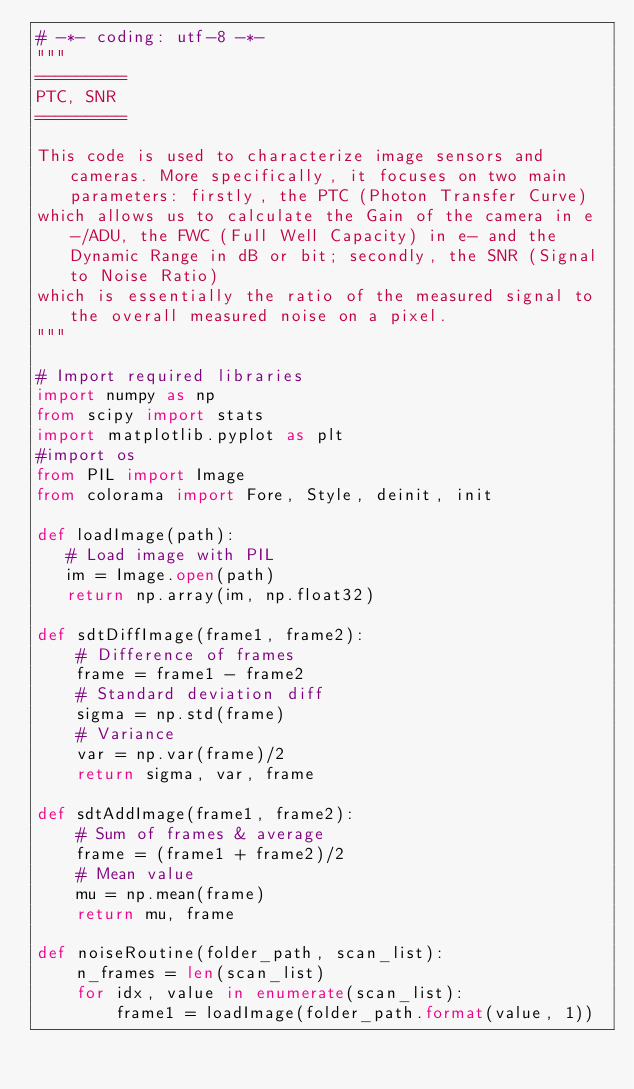<code> <loc_0><loc_0><loc_500><loc_500><_Python_># -*- coding: utf-8 -*-
"""
=========
PTC, SNR
=========

This code is used to characterize image sensors and cameras. More specifically, it focuses on two main parameters: firstly, the PTC (Photon Transfer Curve) 
which allows us to calculate the Gain of the camera in e-/ADU, the FWC (Full Well Capacity) in e- and the Dynamic Range in dB or bit; secondly, the SNR (Signal to Noise Ratio) 
which is essentially the ratio of the measured signal to the overall measured noise on a pixel.
"""

# Import required libraries
import numpy as np
from scipy import stats
import matplotlib.pyplot as plt
#import os
from PIL import Image
from colorama import Fore, Style, deinit, init

def loadImage(path):
   # Load image with PIL
   im = Image.open(path)
   return np.array(im, np.float32)
   
def sdtDiffImage(frame1, frame2):
    # Difference of frames
    frame = frame1 - frame2
    # Standard deviation diff
    sigma = np.std(frame)
    # Variance
    var = np.var(frame)/2  
    return sigma, var, frame

def sdtAddImage(frame1, frame2):
    # Sum of frames & average
    frame = (frame1 + frame2)/2 
    # Mean value
    mu = np.mean(frame)
    return mu, frame
    
def noiseRoutine(folder_path, scan_list):
    n_frames = len(scan_list)
    for idx, value in enumerate(scan_list):
        frame1 = loadImage(folder_path.format(value, 1))</code> 